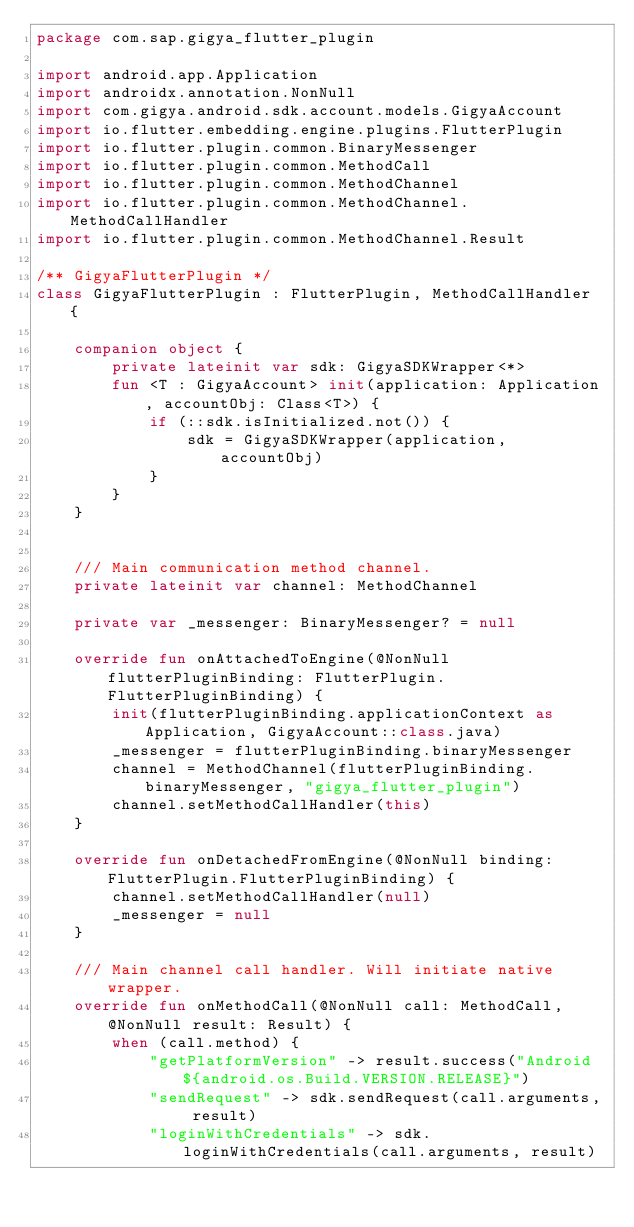<code> <loc_0><loc_0><loc_500><loc_500><_Kotlin_>package com.sap.gigya_flutter_plugin

import android.app.Application
import androidx.annotation.NonNull
import com.gigya.android.sdk.account.models.GigyaAccount
import io.flutter.embedding.engine.plugins.FlutterPlugin
import io.flutter.plugin.common.BinaryMessenger
import io.flutter.plugin.common.MethodCall
import io.flutter.plugin.common.MethodChannel
import io.flutter.plugin.common.MethodChannel.MethodCallHandler
import io.flutter.plugin.common.MethodChannel.Result

/** GigyaFlutterPlugin */
class GigyaFlutterPlugin : FlutterPlugin, MethodCallHandler {

    companion object {
        private lateinit var sdk: GigyaSDKWrapper<*>
        fun <T : GigyaAccount> init(application: Application, accountObj: Class<T>) {
            if (::sdk.isInitialized.not()) {
                sdk = GigyaSDKWrapper(application, accountObj)
            }
        }
    }


    /// Main communication method channel.
    private lateinit var channel: MethodChannel

    private var _messenger: BinaryMessenger? = null

    override fun onAttachedToEngine(@NonNull flutterPluginBinding: FlutterPlugin.FlutterPluginBinding) {
        init(flutterPluginBinding.applicationContext as Application, GigyaAccount::class.java)
        _messenger = flutterPluginBinding.binaryMessenger
        channel = MethodChannel(flutterPluginBinding.binaryMessenger, "gigya_flutter_plugin")
        channel.setMethodCallHandler(this)
    }

    override fun onDetachedFromEngine(@NonNull binding: FlutterPlugin.FlutterPluginBinding) {
        channel.setMethodCallHandler(null)
        _messenger = null
    }

    /// Main channel call handler. Will initiate native wrapper.
    override fun onMethodCall(@NonNull call: MethodCall, @NonNull result: Result) {
        when (call.method) {
            "getPlatformVersion" -> result.success("Android ${android.os.Build.VERSION.RELEASE}")
            "sendRequest" -> sdk.sendRequest(call.arguments, result)
            "loginWithCredentials" -> sdk.loginWithCredentials(call.arguments, result)</code> 